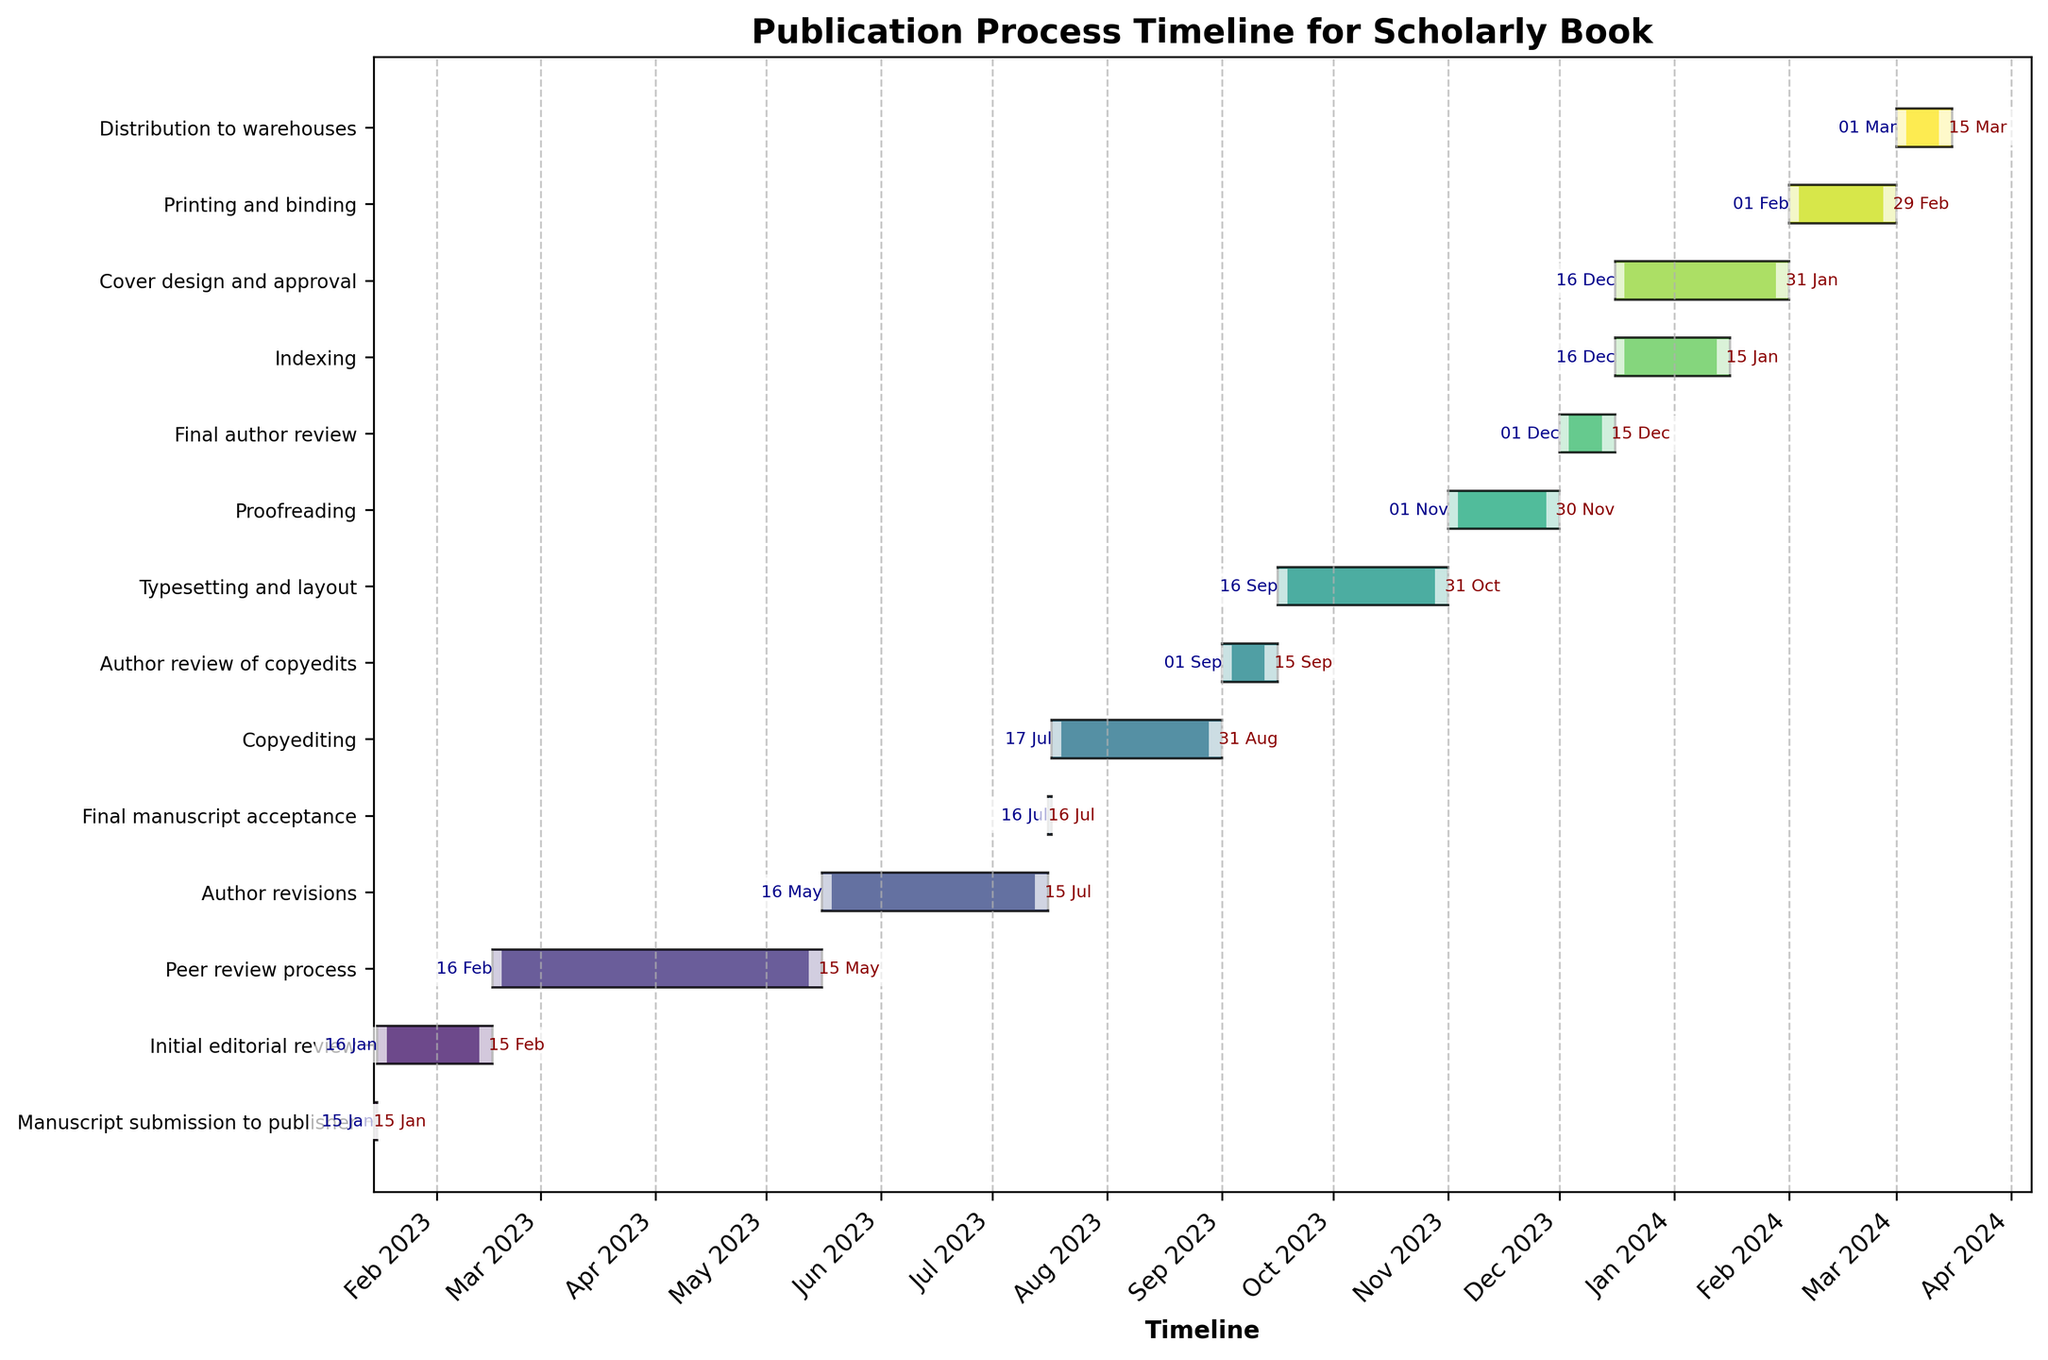What is the title of the Gantt chart? The title of the Gantt chart can be found at the top of the figure, usually in larger or bold text.
Answer: Publication Process Timeline for Scholarly Book How long is the peer review process? The duration of the peer review process is found by looking at the start and end dates for the "Peer review process" task on the y-axis and calculating the difference.
Answer: 3 months What is the duration of the shortest task? Identify the shortest bar in the chart, then check the task and the difference between the start and end dates for that task.
Answer: Manuscript submission to publisher and Final manuscript acceptance, both 1 day Compare the duration of Copyediting and Proofreading. Which one is longer and by how much? Find the duration for both tasks. Copyediting lasts from July 17 to August 31 (46 days), and Proofreading lasts from November 1 to November 30 (30 days). Therefore, Copyediting is longer by 16 days.
Answer: Copyediting is 16 days longer How many tasks overlap with the Indexing task? Identify the start and end dates for the "Indexing" task. Then, check which other tasks have bars that overlap in this timeline.
Answer: 2 (Cover design and approval, Final author review) What task begins immediately after the Initial editorial review? Find the end date of the "Initial editorial review" task and see which task starts right after that date.
Answer: Peer review process When is the final author review scheduled to end? Look at the end date for the "Final author review" task on the y-axis.
Answer: December 15, 2023 Which task takes the longest duration in the process? Compare the lengths of the bars. The longest bar represents the task with the longest duration.
Answer: Peer review process What is the total duration from Manuscript submission to Distribution to warehouses? Calculate the difference between the start date of the first task "Manuscript submission to publisher" and the end date of the last task "Distribution to warehouses".
Answer: Approximately 14 months How do the durations of Cover design and approval and Printing and binding compare? Find the durations for both tasks and compare. Cover design and approval lasts from December 16, 2023, to January 31, 2024 (47 days), and Printing and binding lasts from February 1, 2024, to February 29, 2024 (29 days). Cover design and approval is longer by 18 days.
Answer: Cover design and approval is 18 days longer 